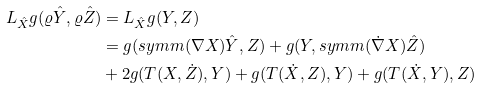<formula> <loc_0><loc_0><loc_500><loc_500>L _ { \hat { X } } g ( \varrho \hat { Y } , \varrho \hat { Z } ) & = L _ { \hat { X } } g ( Y , Z ) \\ & = g ( s y m m ( \nabla X ) \hat { Y } , Z ) + g ( Y , s y m m ( \dot { \nabla } X ) \hat { Z } ) \\ & + 2 g ( T ( X , \dot { Z } ) , Y ) + g ( T ( \dot { X } , Z ) , Y ) + g ( T ( \dot { X } , Y ) , Z )</formula> 